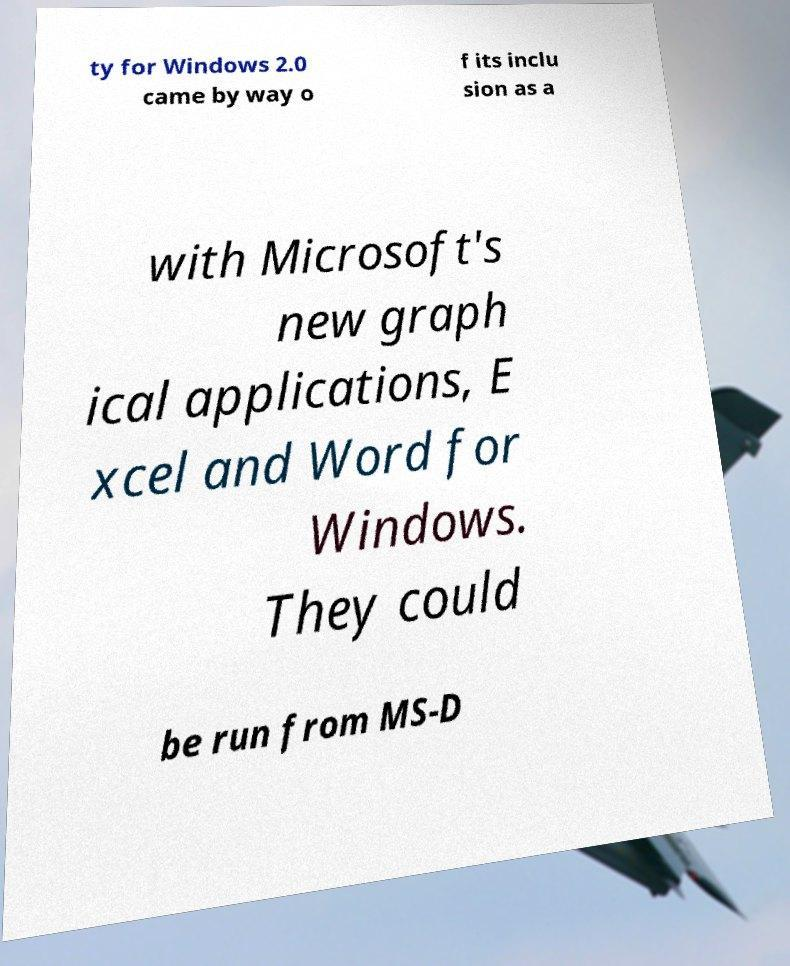Could you assist in decoding the text presented in this image and type it out clearly? ty for Windows 2.0 came by way o f its inclu sion as a with Microsoft's new graph ical applications, E xcel and Word for Windows. They could be run from MS-D 